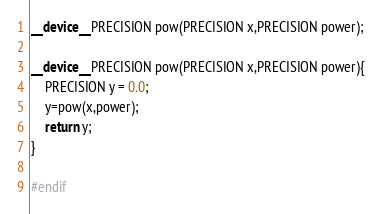Convert code to text. <code><loc_0><loc_0><loc_500><loc_500><_Cuda_>__device__ PRECISION pow(PRECISION x,PRECISION power);

__device__ PRECISION pow(PRECISION x,PRECISION power){
    PRECISION y = 0.0;
    y=pow(x,power);
    return y;
}

#endif
</code> 